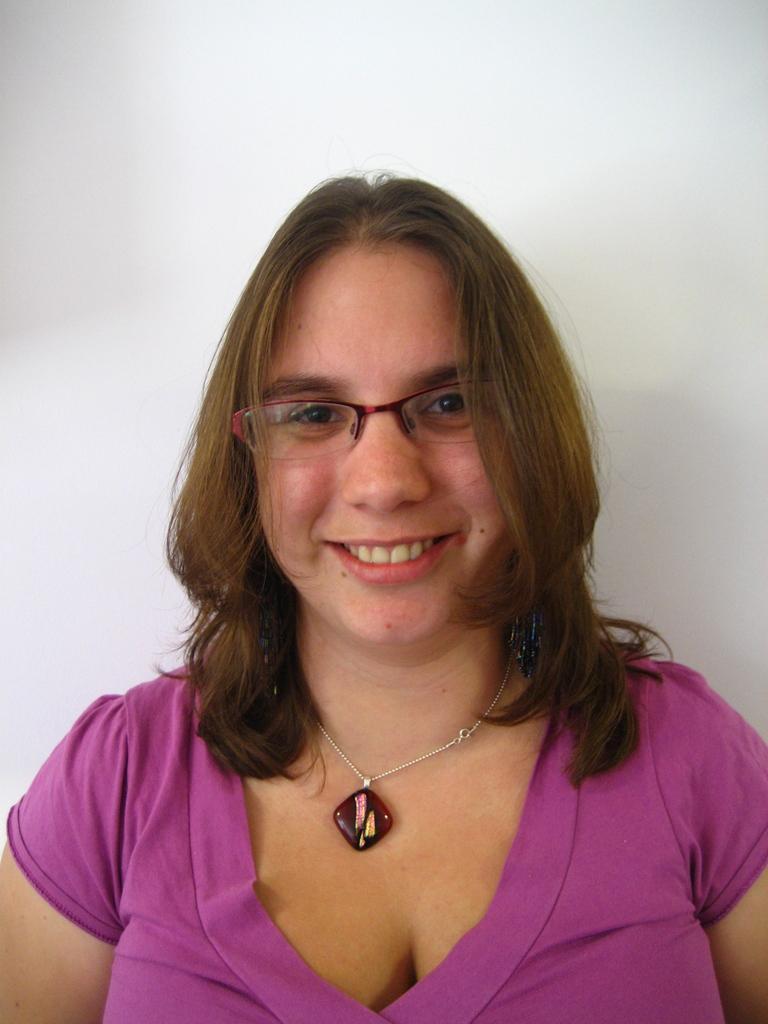In one or two sentences, can you explain what this image depicts? In this image, we can see a woman wearing a pink color dress. In the background, we can see a wall. 